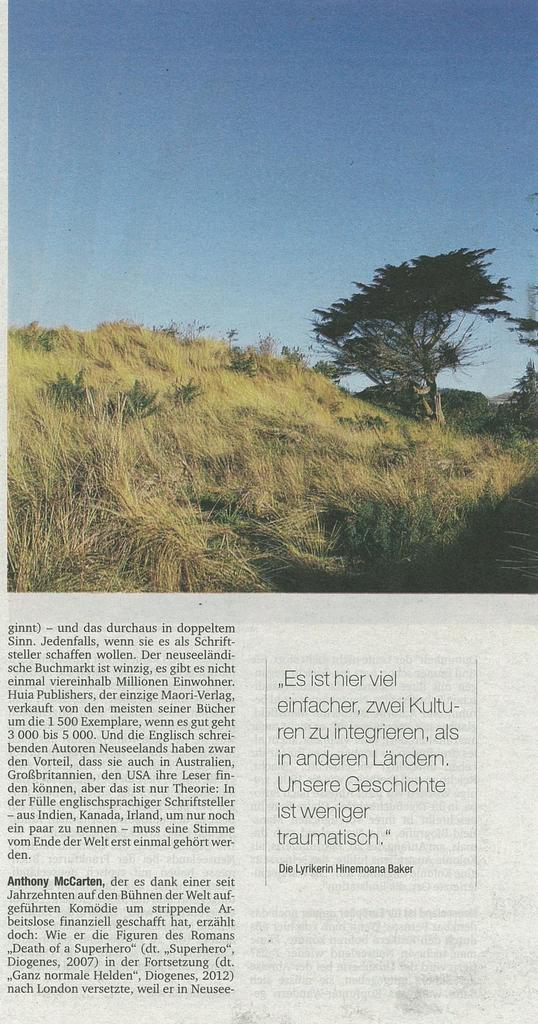What is the main subject of the image? There is an article in the image. What is featured within the article? There is a picture in the article. What can be seen in the picture? The picture contains grass, trees, and the sky. How does the worm interact with the grass in the image? There is no worm present in the image; it only contains grass, trees, and the sky. 